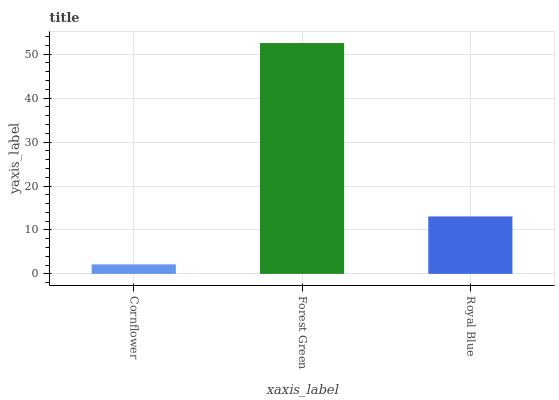Is Cornflower the minimum?
Answer yes or no. Yes. Is Forest Green the maximum?
Answer yes or no. Yes. Is Royal Blue the minimum?
Answer yes or no. No. Is Royal Blue the maximum?
Answer yes or no. No. Is Forest Green greater than Royal Blue?
Answer yes or no. Yes. Is Royal Blue less than Forest Green?
Answer yes or no. Yes. Is Royal Blue greater than Forest Green?
Answer yes or no. No. Is Forest Green less than Royal Blue?
Answer yes or no. No. Is Royal Blue the high median?
Answer yes or no. Yes. Is Royal Blue the low median?
Answer yes or no. Yes. Is Cornflower the high median?
Answer yes or no. No. Is Forest Green the low median?
Answer yes or no. No. 